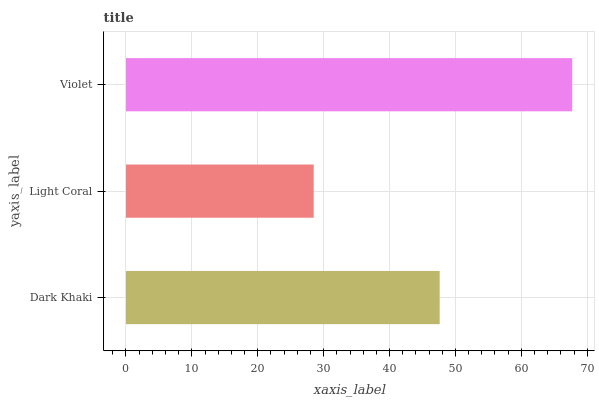Is Light Coral the minimum?
Answer yes or no. Yes. Is Violet the maximum?
Answer yes or no. Yes. Is Violet the minimum?
Answer yes or no. No. Is Light Coral the maximum?
Answer yes or no. No. Is Violet greater than Light Coral?
Answer yes or no. Yes. Is Light Coral less than Violet?
Answer yes or no. Yes. Is Light Coral greater than Violet?
Answer yes or no. No. Is Violet less than Light Coral?
Answer yes or no. No. Is Dark Khaki the high median?
Answer yes or no. Yes. Is Dark Khaki the low median?
Answer yes or no. Yes. Is Light Coral the high median?
Answer yes or no. No. Is Violet the low median?
Answer yes or no. No. 